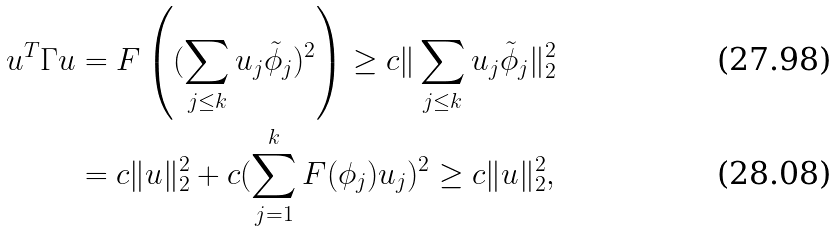Convert formula to latex. <formula><loc_0><loc_0><loc_500><loc_500>u ^ { T } \Gamma u & = F \left ( ( \sum _ { j \leq k } u _ { j } \tilde { \phi } _ { j } ) ^ { 2 } \right ) \geq c \| \sum _ { j \leq k } u _ { j } \tilde { \phi } _ { j } \| _ { 2 } ^ { 2 } \\ & = c \| u \| _ { 2 } ^ { 2 } + c ( \sum _ { j = 1 } ^ { k } F ( \phi _ { j } ) u _ { j } ) ^ { 2 } \geq c \| u \| _ { 2 } ^ { 2 } ,</formula> 